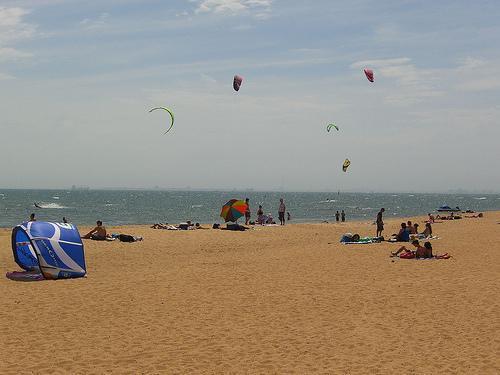How many kites are flying?
Give a very brief answer. 5. How many umbrellas are there?
Give a very brief answer. 1. How many kites have the color green?
Give a very brief answer. 2. 